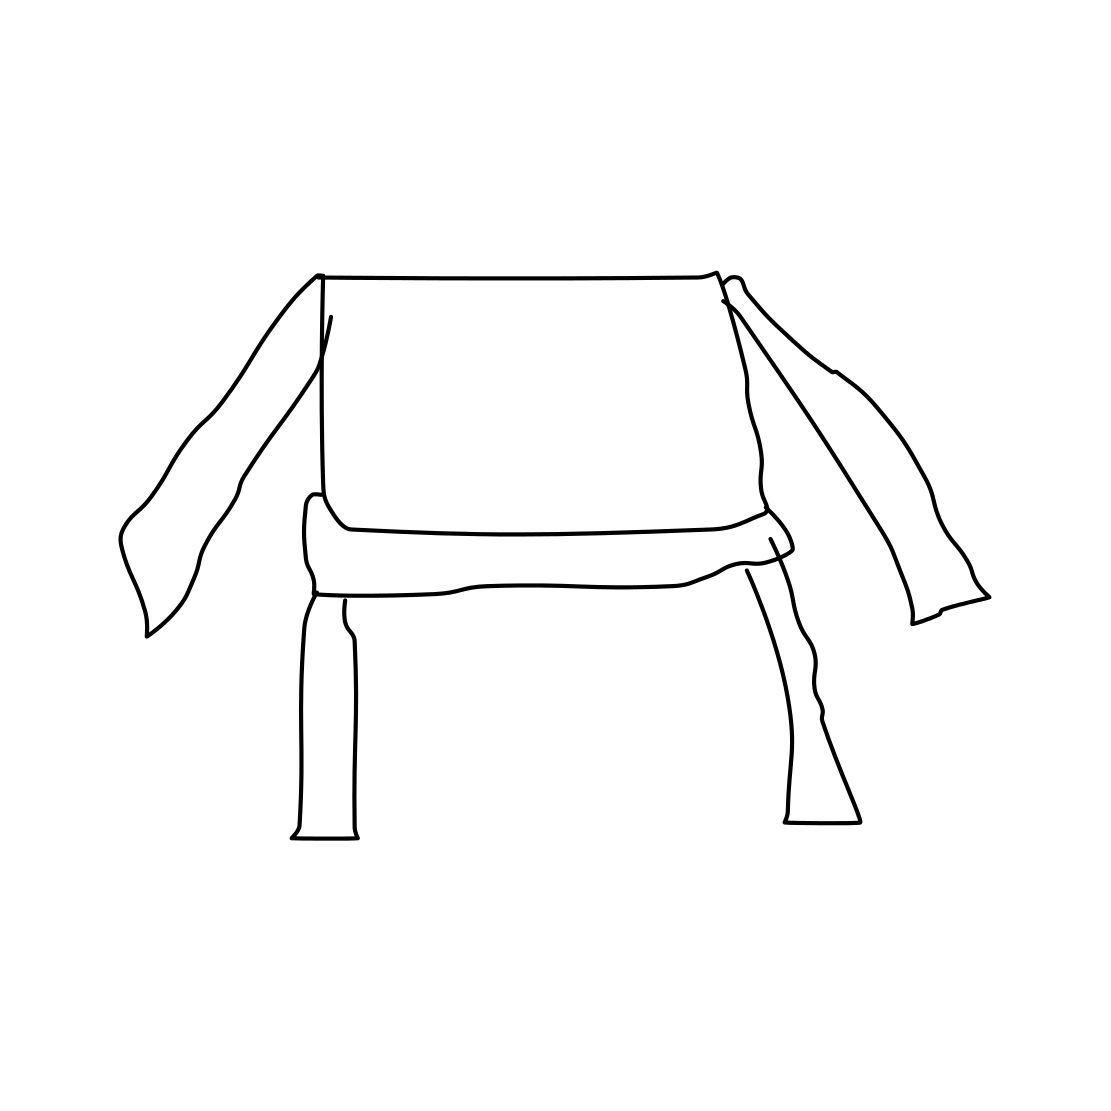Could this image serve as a logo for a brand? Indeed, this image could serve as a logo, especially for a brand that values simplicity, modernity, and creative design. Its distinctive appearance would make it memorable and easily recognizable, reflecting the unique identity of the brand. 